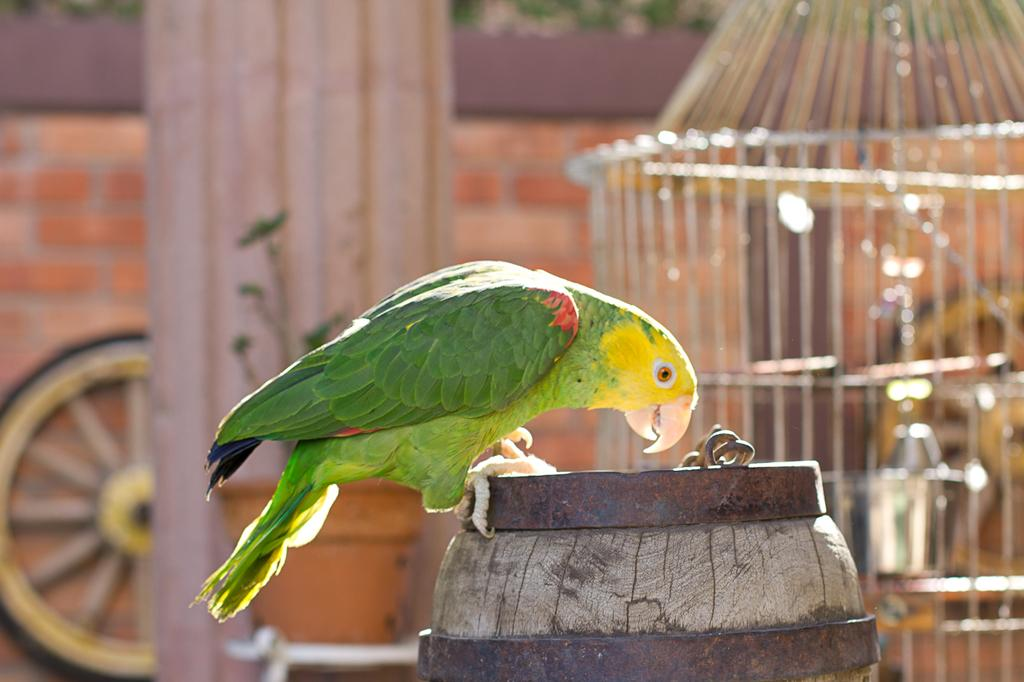What type of animal is in the image? There is a parrot in the image. Where is the parrot located? The parrot is on a barrel. What can be seen in the background of the image? There is a cage and a wheel in the background of the image. What type of bubble can be seen in the image? There is no bubble present in the image. How does the parrot's growth affect the cage in the image? The parrot's growth is not mentioned in the image, and there is no indication of the cage's size or the parrot's size. 